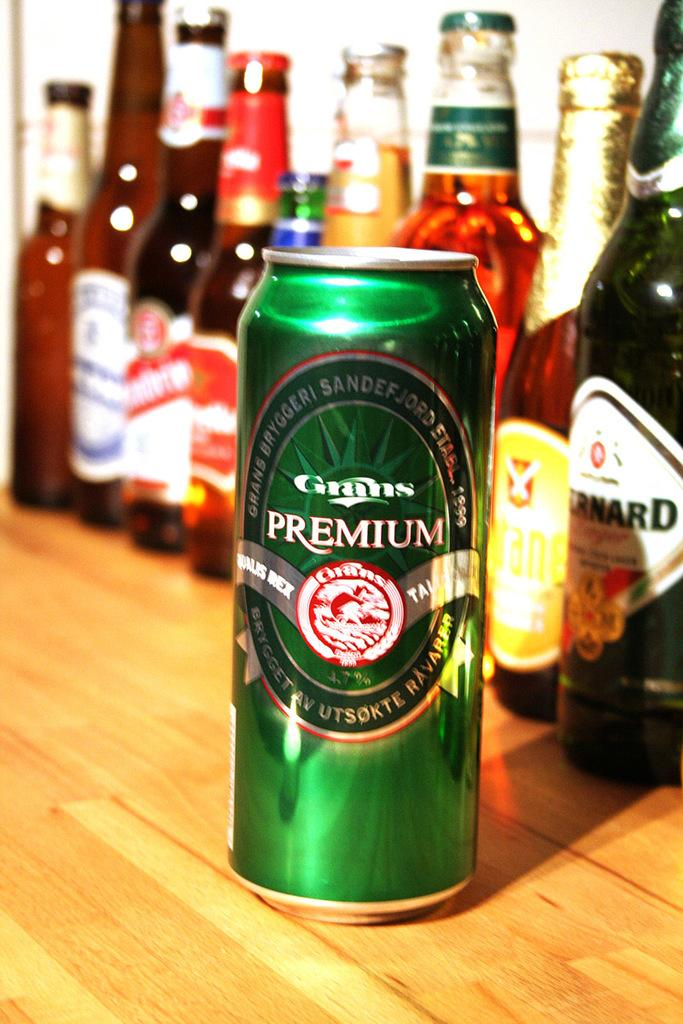<image>
Present a compact description of the photo's key features. A variety of bottles lined up and a can green can of Grans Premium in front of the labels 